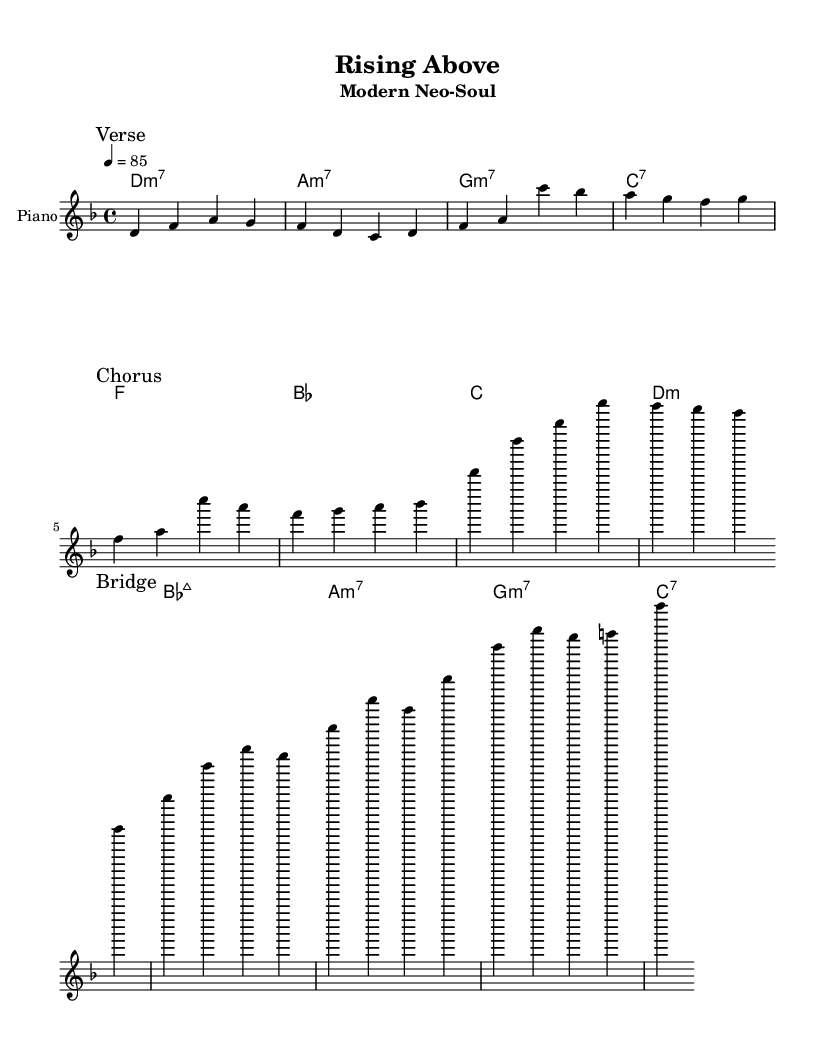What is the key signature of this music? The key signature is D minor, which has one flat (B flat) indicating that the music is in a minor key.
Answer: D minor What is the time signature of this music? The time signature is 4/4, which means there are four beats in each measure and a quarter note receives one beat.
Answer: 4/4 What is the tempo of this music? The tempo marking indicates that the piece should be played at a speed of 85 beats per minute, which is noted as quarter note = 85.
Answer: 85 How many measures are in the verse section? The verse section contains 4 measures as represented in the score before a break indicating a change to the chorus.
Answer: 4 What is the first chord of the chorus? The first chord of the chorus is F major, which appears as the first harmony in the chorus section of the score.
Answer: F What theme is explored in the lyrics of this song? The lyrics explore themes of resilience and overcoming challenges, specifically in the context of property development and risk management.
Answer: Resilience How many distinct sections does this piece have? The piece has three distinct sections: Verse, Chorus, and Bridge, as denoted by the markings in the score.
Answer: 3 